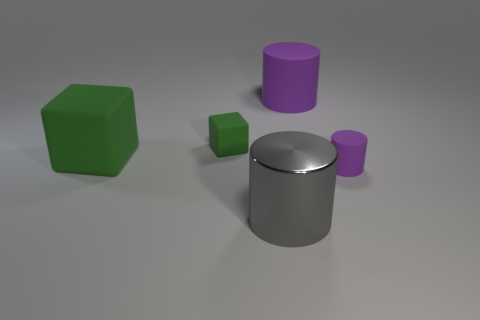Is there another tiny purple rubber thing that has the same shape as the tiny purple thing?
Provide a succinct answer. No. There is a thing that is both behind the gray object and in front of the big green block; what shape is it?
Keep it short and to the point. Cylinder. Does the large block have the same material as the green cube behind the big green matte cube?
Offer a very short reply. Yes. Are there any large matte objects in front of the small purple object?
Offer a terse response. No. What number of objects are purple matte objects or matte cylinders in front of the large green matte thing?
Your answer should be very brief. 2. There is a small object that is behind the small rubber object right of the large metal object; what color is it?
Your answer should be very brief. Green. What number of other things are there of the same material as the gray object
Offer a terse response. 0. How many shiny objects are either green things or tiny purple cylinders?
Make the answer very short. 0. There is a large matte thing that is the same shape as the big gray metal object; what color is it?
Your response must be concise. Purple. What number of objects are tiny red matte cylinders or cylinders?
Your answer should be compact. 3. 